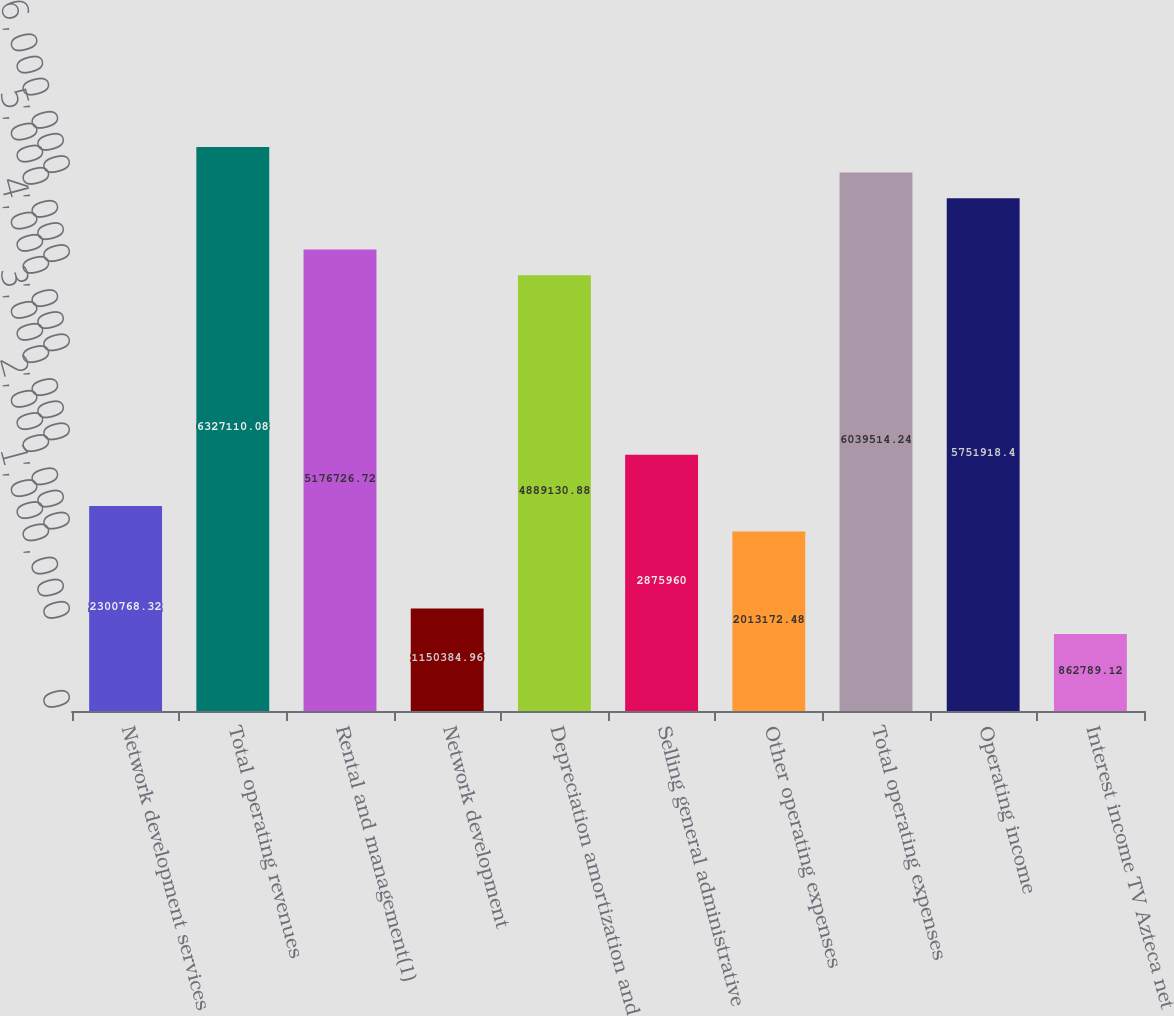<chart> <loc_0><loc_0><loc_500><loc_500><bar_chart><fcel>Network development services<fcel>Total operating revenues<fcel>Rental and management(1)<fcel>Network development<fcel>Depreciation amortization and<fcel>Selling general administrative<fcel>Other operating expenses<fcel>Total operating expenses<fcel>Operating income<fcel>Interest income TV Azteca net<nl><fcel>2.30077e+06<fcel>6.32711e+06<fcel>5.17673e+06<fcel>1.15038e+06<fcel>4.88913e+06<fcel>2.87596e+06<fcel>2.01317e+06<fcel>6.03951e+06<fcel>5.75192e+06<fcel>862789<nl></chart> 